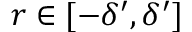<formula> <loc_0><loc_0><loc_500><loc_500>r \in [ - \delta ^ { \prime } , \delta ^ { \prime } ]</formula> 